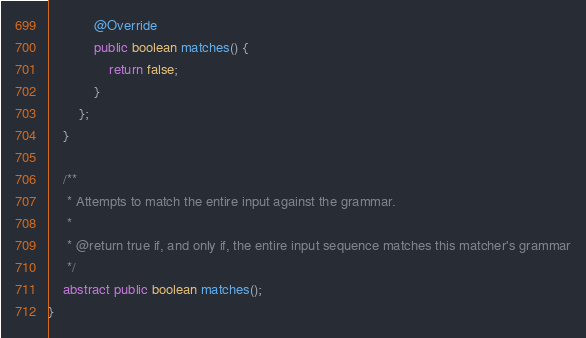Convert code to text. <code><loc_0><loc_0><loc_500><loc_500><_Java_>            @Override
            public boolean matches() {
                return false;
            }
        };
    }

    /**
     * Attempts to match the entire input against the grammar.
     *
     * @return true if, and only if, the entire input sequence matches this matcher's grammar
     */
    abstract public boolean matches();
}
</code> 